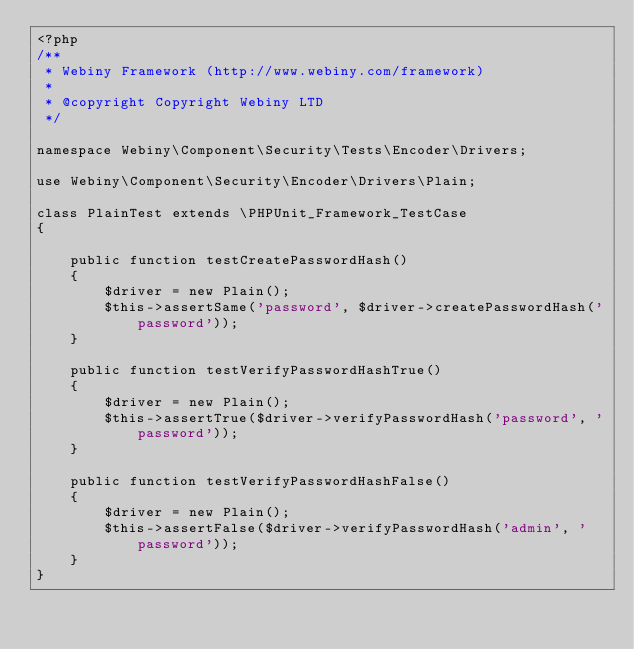Convert code to text. <code><loc_0><loc_0><loc_500><loc_500><_PHP_><?php
/**
 * Webiny Framework (http://www.webiny.com/framework)
 *
 * @copyright Copyright Webiny LTD
 */

namespace Webiny\Component\Security\Tests\Encoder\Drivers;

use Webiny\Component\Security\Encoder\Drivers\Plain;

class PlainTest extends \PHPUnit_Framework_TestCase
{

    public function testCreatePasswordHash()
    {
        $driver = new Plain();
        $this->assertSame('password', $driver->createPasswordHash('password'));
    }

    public function testVerifyPasswordHashTrue()
    {
        $driver = new Plain();
        $this->assertTrue($driver->verifyPasswordHash('password', 'password'));
    }

    public function testVerifyPasswordHashFalse()
    {
        $driver = new Plain();
        $this->assertFalse($driver->verifyPasswordHash('admin', 'password'));
    }
}</code> 